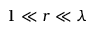<formula> <loc_0><loc_0><loc_500><loc_500>1 \ll r \ll \lambda</formula> 